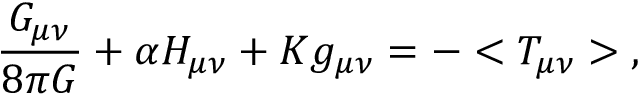Convert formula to latex. <formula><loc_0><loc_0><loc_500><loc_500>\frac { G _ { \mu \nu } } { 8 \pi G } + \alpha H _ { \mu \nu } + K g _ { \mu \nu } = - < T _ { \mu \nu } > \, ,</formula> 